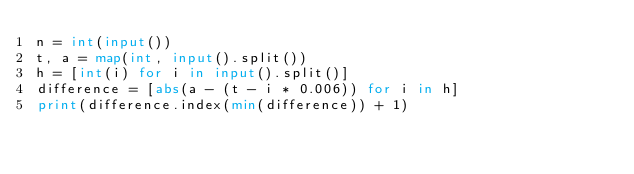Convert code to text. <code><loc_0><loc_0><loc_500><loc_500><_Python_>n = int(input())
t, a = map(int, input().split())
h = [int(i) for i in input().split()]
difference = [abs(a - (t - i * 0.006)) for i in h]
print(difference.index(min(difference)) + 1)
</code> 